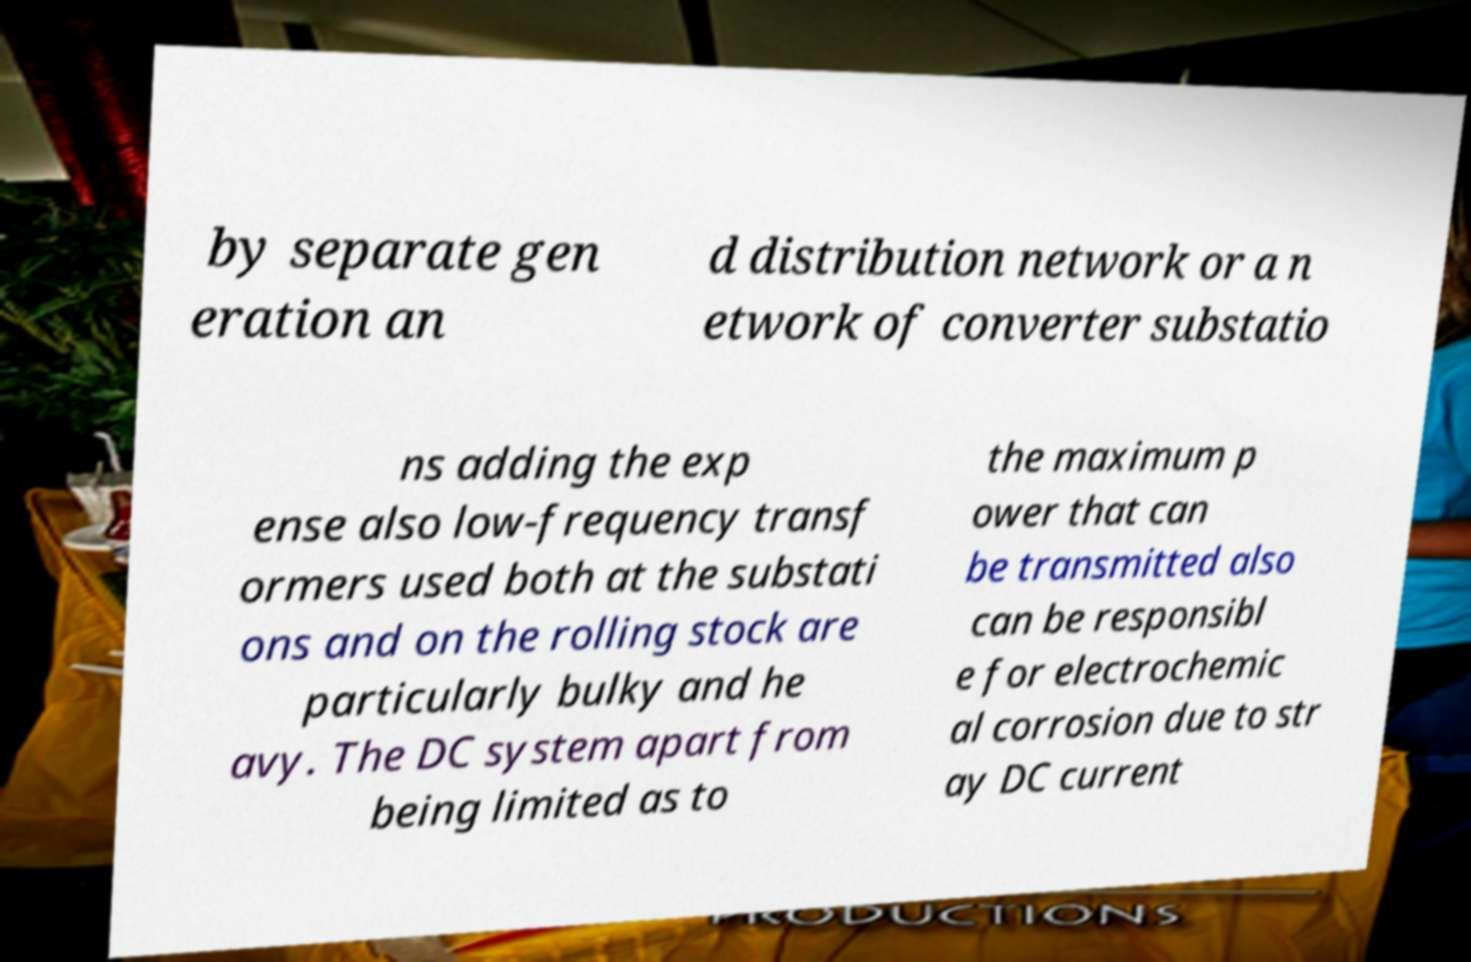Please read and relay the text visible in this image. What does it say? by separate gen eration an d distribution network or a n etwork of converter substatio ns adding the exp ense also low-frequency transf ormers used both at the substati ons and on the rolling stock are particularly bulky and he avy. The DC system apart from being limited as to the maximum p ower that can be transmitted also can be responsibl e for electrochemic al corrosion due to str ay DC current 